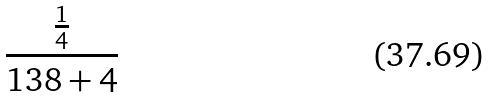<formula> <loc_0><loc_0><loc_500><loc_500>\frac { \frac { 1 } { 4 } } { 1 3 8 + 4 }</formula> 